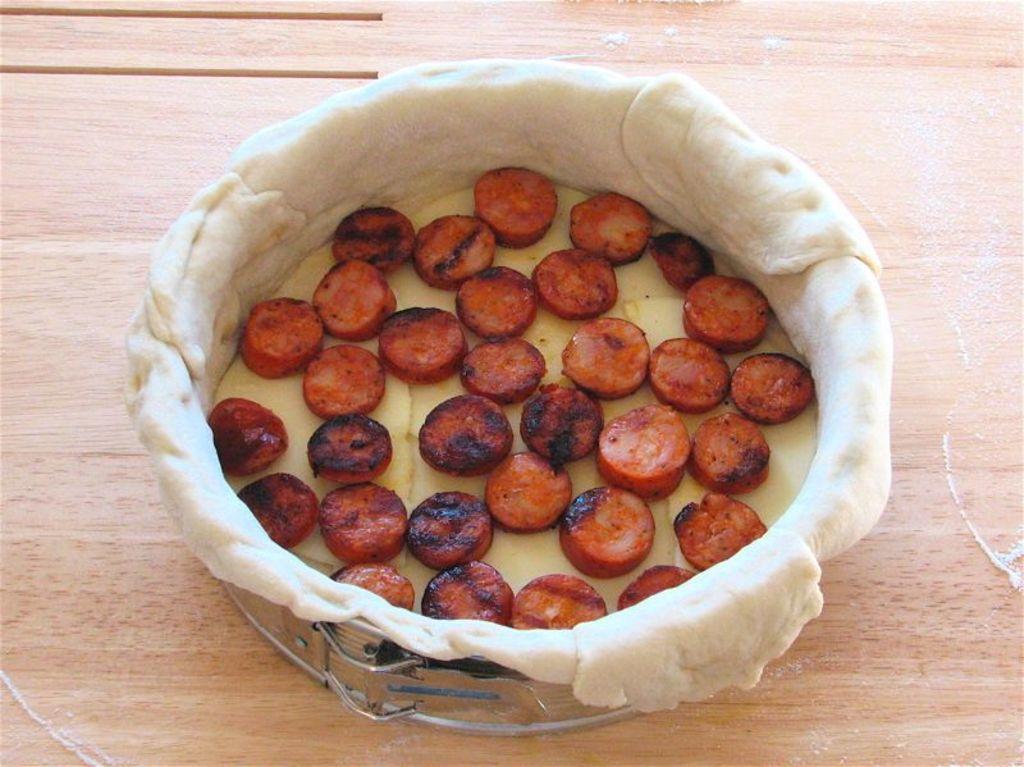Please provide a concise description of this image. In this image we can see a food item in a container is kept on a wooden surface. 